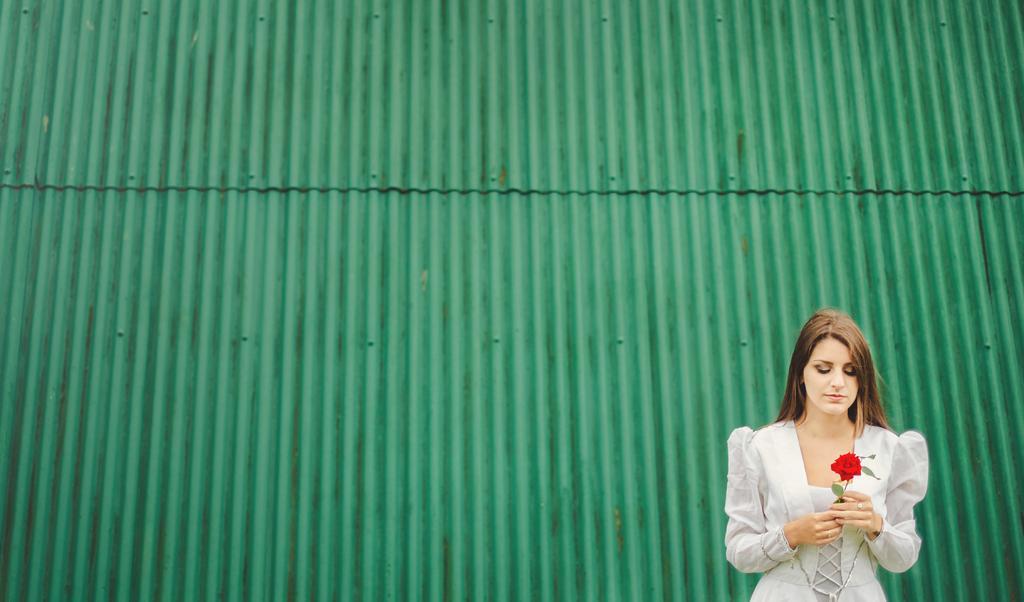Could you give a brief overview of what you see in this image? In the image we can see a girl standing, wearing clothes and holding a flower in her hand. The flower is red in color, this is a fingering and the background is red in color. 